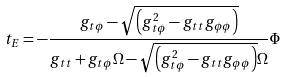<formula> <loc_0><loc_0><loc_500><loc_500>t _ { E } = - \frac { g _ { t \phi } - \sqrt { \left ( g _ { t \phi } ^ { 2 } - g _ { t t } g _ { \phi \phi } \right ) } } { g _ { t t } + g _ { t \phi } \Omega - \sqrt { \left ( g _ { t \phi } ^ { 2 } - g _ { t t } g _ { \phi \phi } \right ) } \Omega } \Phi</formula> 